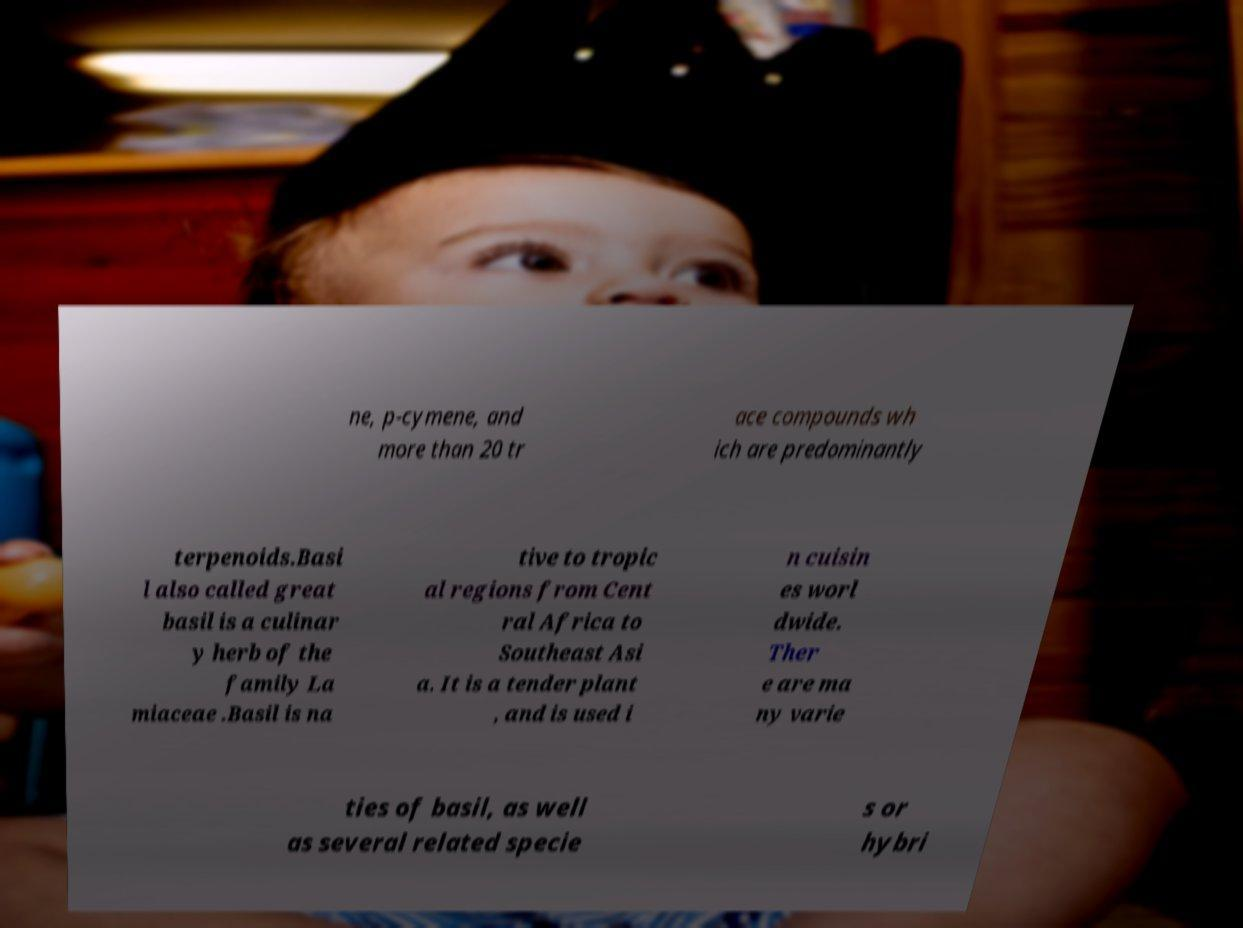There's text embedded in this image that I need extracted. Can you transcribe it verbatim? ne, p-cymene, and more than 20 tr ace compounds wh ich are predominantly terpenoids.Basi l also called great basil is a culinar y herb of the family La miaceae .Basil is na tive to tropic al regions from Cent ral Africa to Southeast Asi a. It is a tender plant , and is used i n cuisin es worl dwide. Ther e are ma ny varie ties of basil, as well as several related specie s or hybri 